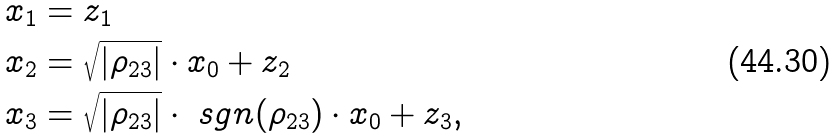<formula> <loc_0><loc_0><loc_500><loc_500>x _ { 1 } & = z _ { 1 } \\ x _ { 2 } & = \sqrt { | \rho _ { 2 3 } | } \cdot x _ { 0 } + z _ { 2 } \\ x _ { 3 } & = \sqrt { | \rho _ { 2 3 } | } \cdot \ s g n ( \rho _ { 2 3 } ) \cdot x _ { 0 } + z _ { 3 } ,</formula> 